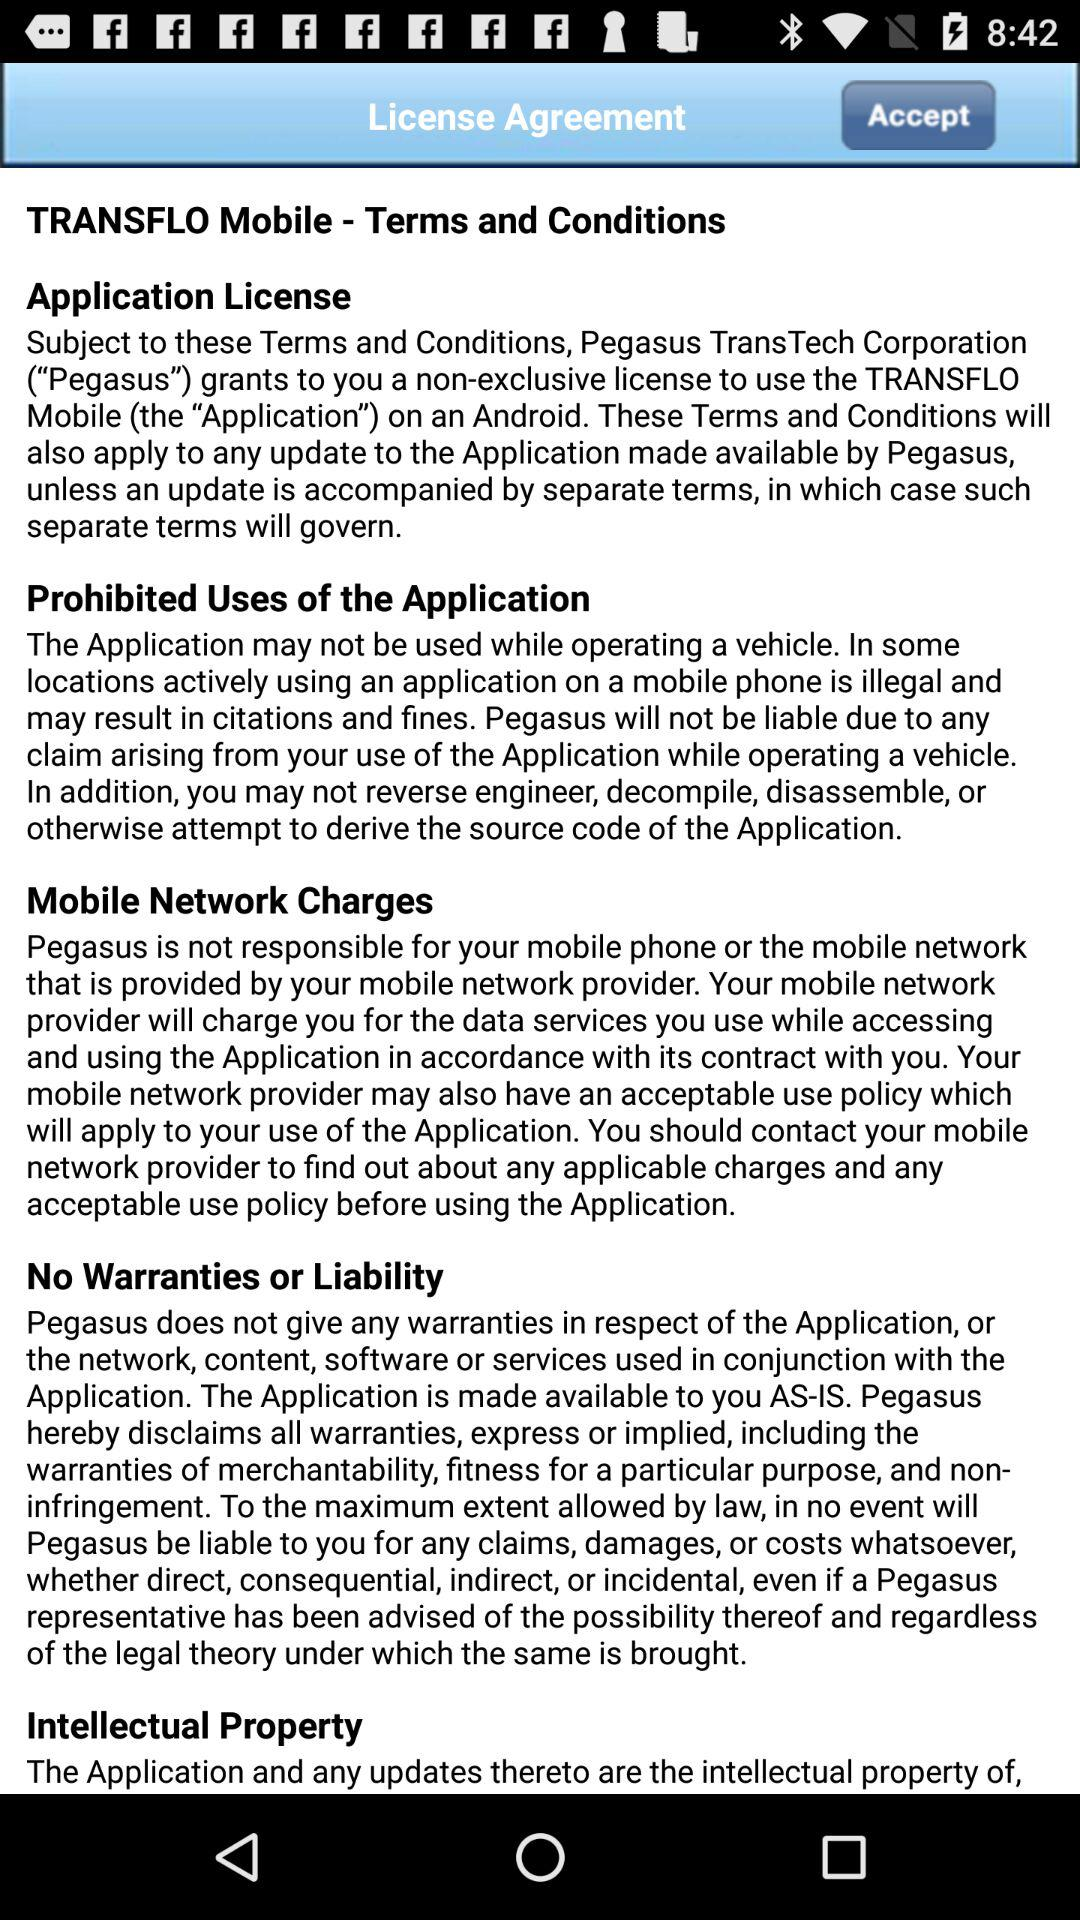What is the name of the application? The name of the application is "TRANSFLO Mobile". 